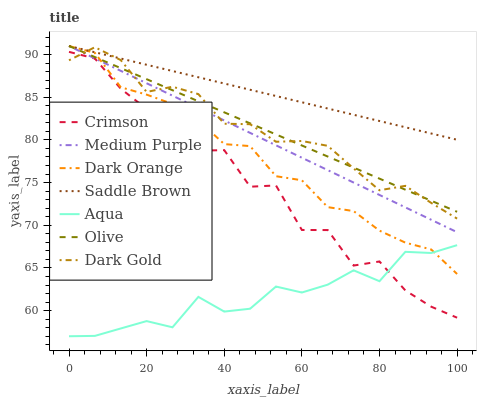Does Aqua have the minimum area under the curve?
Answer yes or no. Yes. Does Saddle Brown have the maximum area under the curve?
Answer yes or no. Yes. Does Dark Gold have the minimum area under the curve?
Answer yes or no. No. Does Dark Gold have the maximum area under the curve?
Answer yes or no. No. Is Medium Purple the smoothest?
Answer yes or no. Yes. Is Crimson the roughest?
Answer yes or no. Yes. Is Dark Gold the smoothest?
Answer yes or no. No. Is Dark Gold the roughest?
Answer yes or no. No. Does Aqua have the lowest value?
Answer yes or no. Yes. Does Dark Gold have the lowest value?
Answer yes or no. No. Does Saddle Brown have the highest value?
Answer yes or no. Yes. Does Dark Gold have the highest value?
Answer yes or no. No. Is Aqua less than Olive?
Answer yes or no. Yes. Is Dark Orange greater than Crimson?
Answer yes or no. Yes. Does Crimson intersect Aqua?
Answer yes or no. Yes. Is Crimson less than Aqua?
Answer yes or no. No. Is Crimson greater than Aqua?
Answer yes or no. No. Does Aqua intersect Olive?
Answer yes or no. No. 